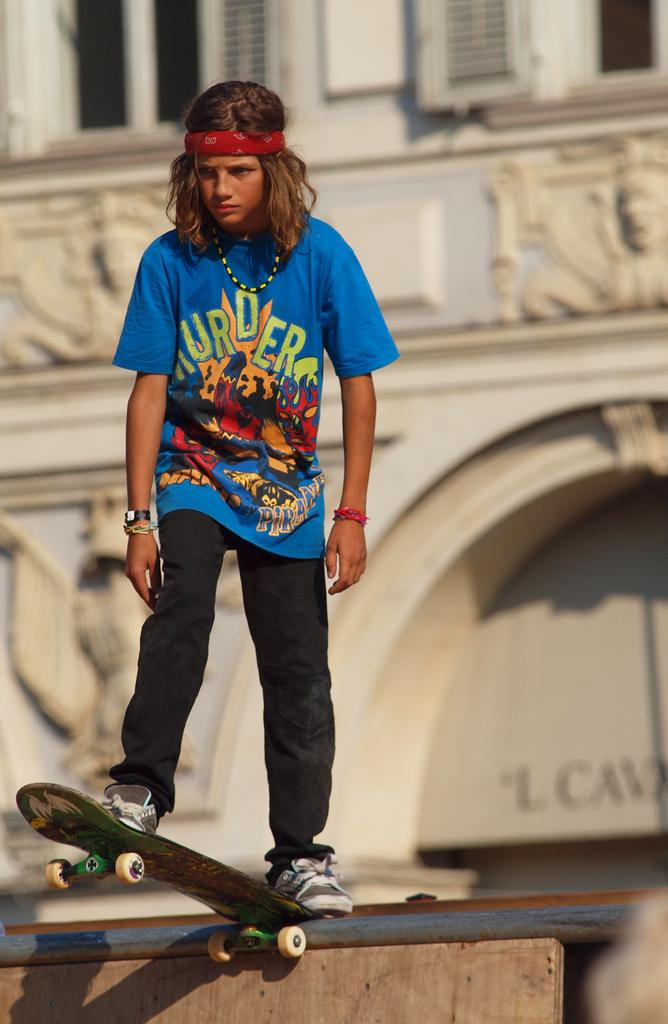What is the main subject of the image? There is a man in the image. What is the man doing in the image? The man is skating. What can be seen in the background of the image? There is a building in the background of the image. Where is the sofa located in the image? There is no sofa present in the image. What type of food is being served in the lunchroom in the image? There is no lunchroom present in the image. 